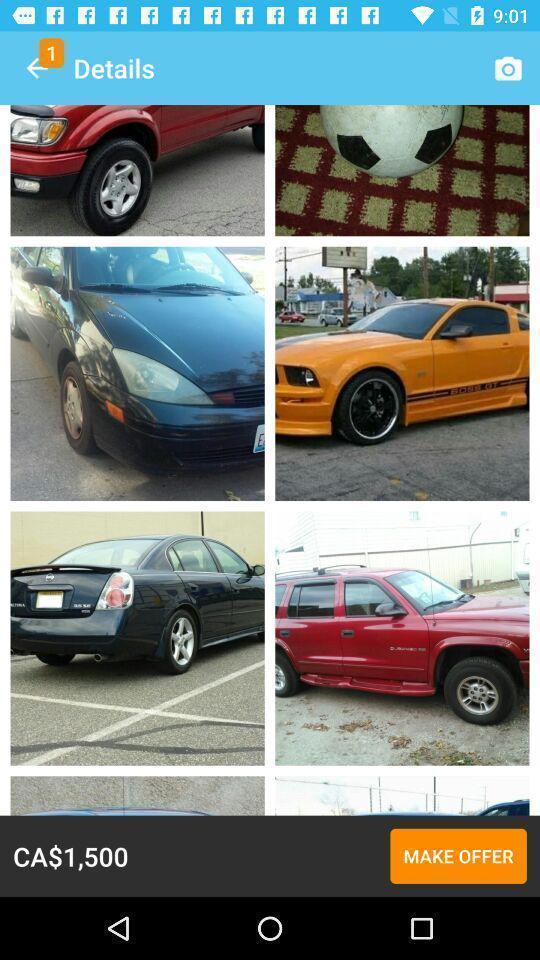Tell me about the visual elements in this screen capture. Page showing details of a car. 